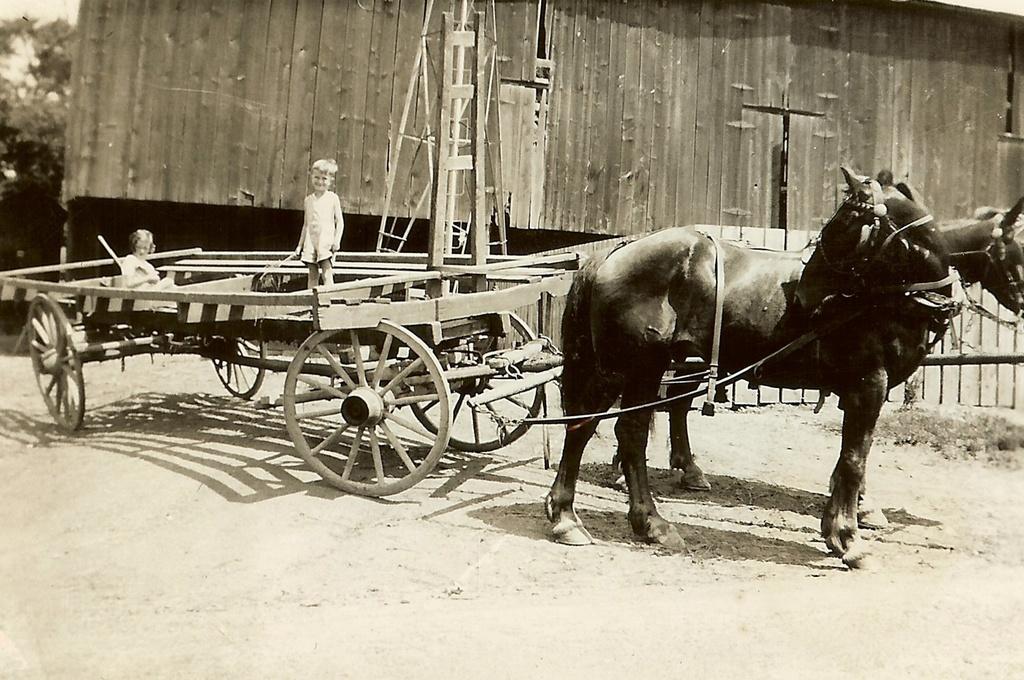In one or two sentences, can you explain what this image depicts? In this picture there is a person standing and there is a person sitting on the cart and there are two horses standing. At the back there is a building and there is a pole and railing and there are trees. At the top there is sky. At the bottom there is mud. 